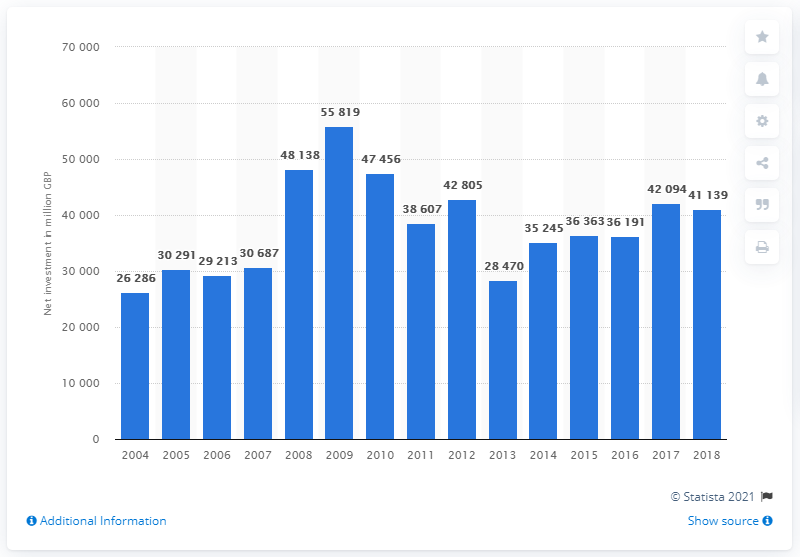Specify some key components in this picture. In 2009, the peak amount of government investment was 55,819. 